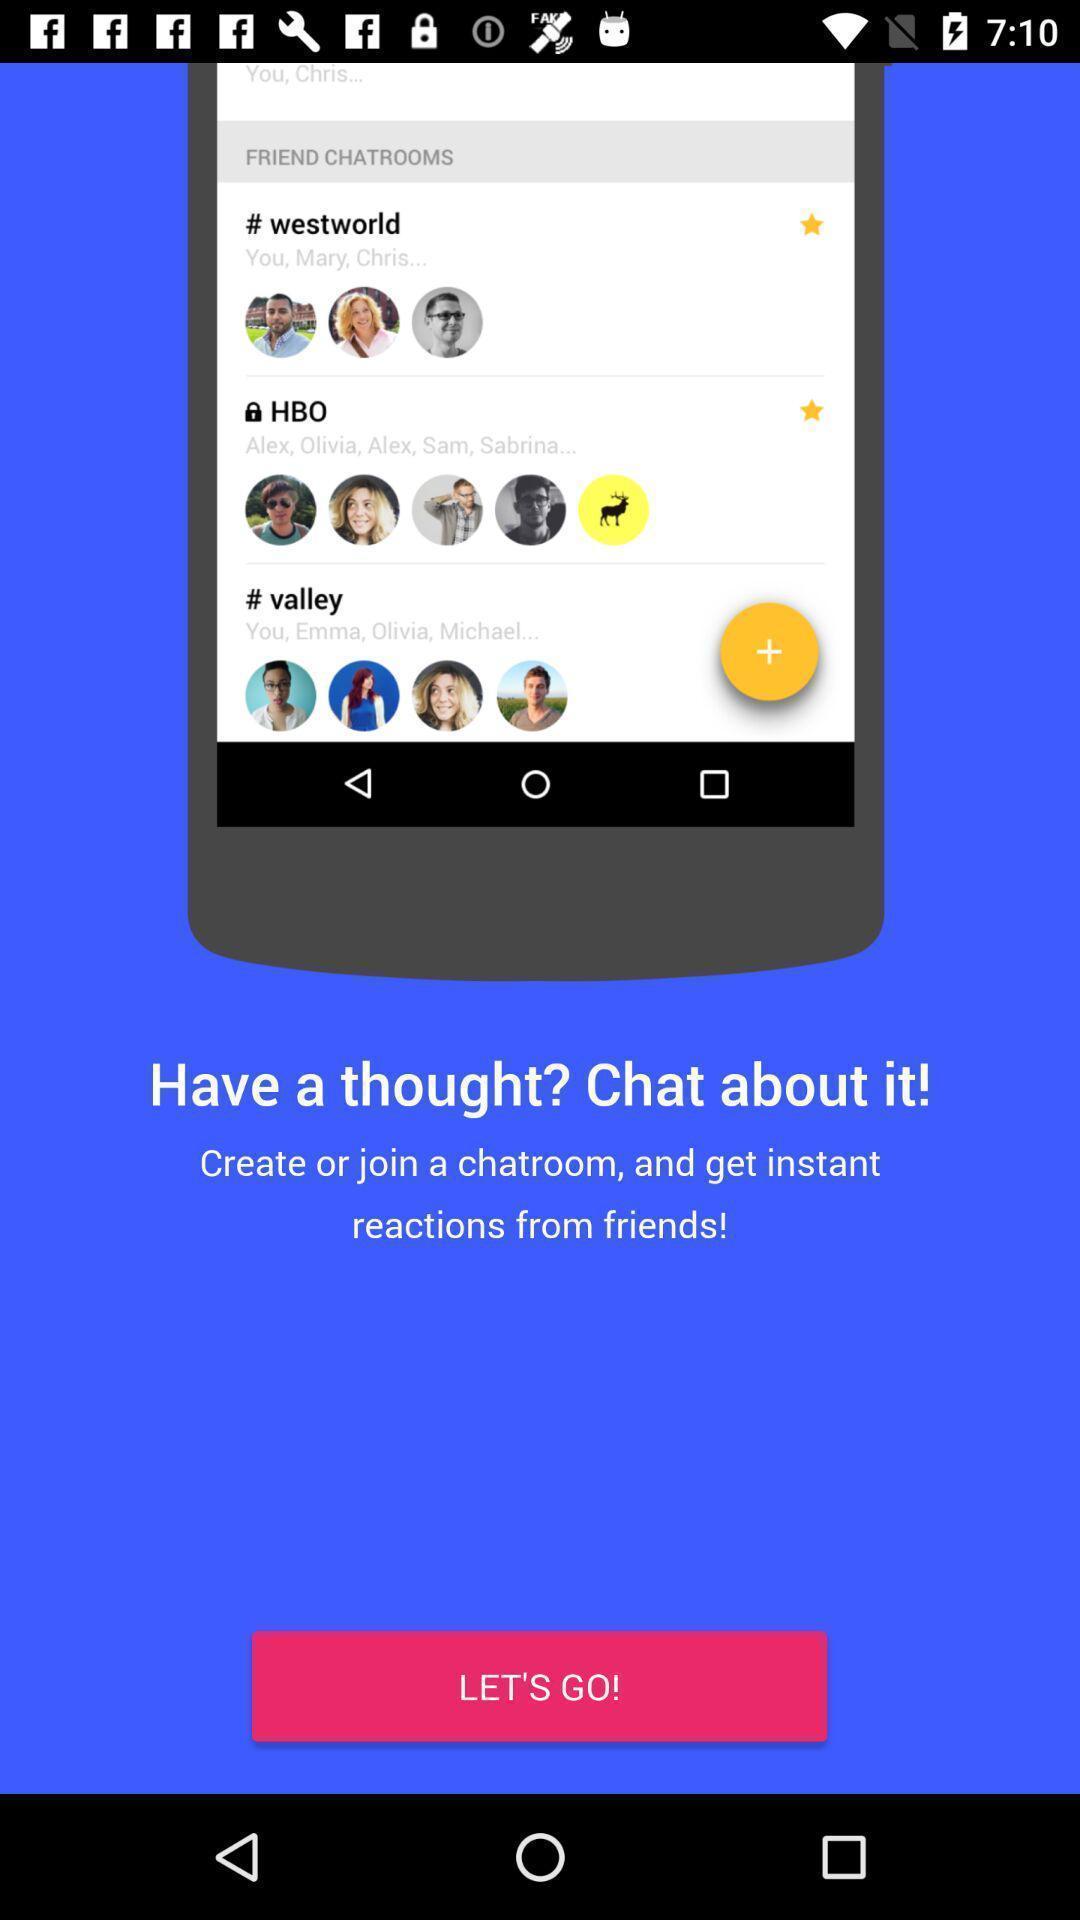Describe this image in words. Welcome page displaying let 's go to start an application. 